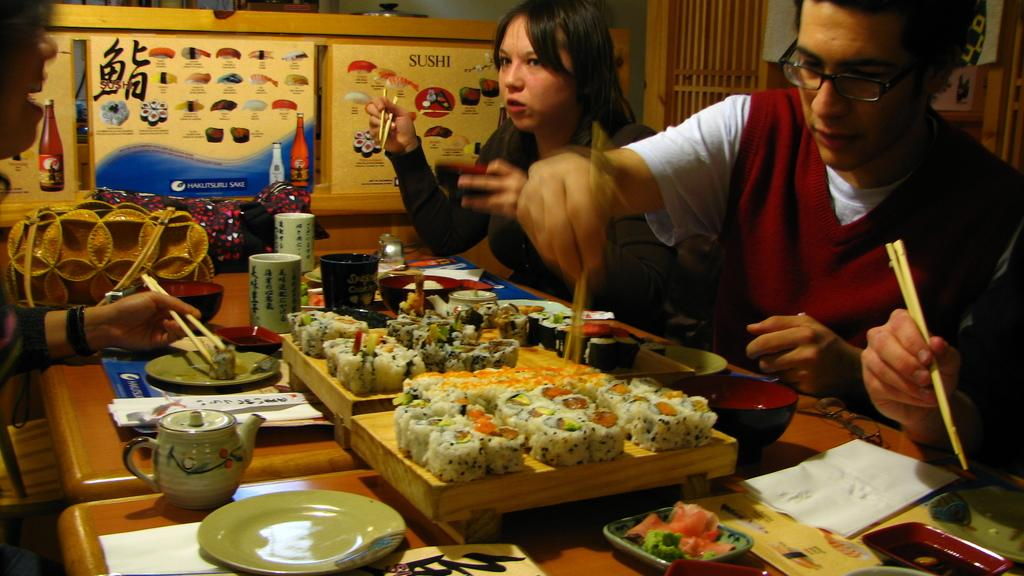Who is present in the image? There are people in the image. What are the people doing in the image? The people are sitting in the image. What are the people holding in the image? The people are holding chopsticks in the image. What can be seen on the tables in the image? There are tables and food on the tables in the image. What type of crime is being committed in the image? There is no crime being committed in the image; it shows people sitting and holding chopsticks. What kind of apparatus is used by the people in the image? The people in the image are using chopsticks, which are not considered an apparatus. 